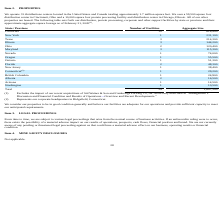From Chefs Wharehouse's financial document, What is the number of facilities in California and New York respectively? The document shows two values: 10 and 1. From the document: "California 10 618,900 California 10 618,900..." Also, What is the number of facilities in Texas and Illinois respectively? The document shows two values: 3 and 3. From the document: "New York 1 231,100..." Also, What is the number of facilities in Ohio and Maryland respectively? The document shows two values: 2 and 3. From the document: "New York 1 231,100 New York 1 231,100..." Also, can you calculate: What is the difference in the number of facilities between California and New York? Based on the calculation: 10-1, the result is 9. This is based on the information: "California 10 618,900 California 10 618,900..." The key data points involved are: 1, 10. Also, can you calculate: What is the average aggregate size of the facilities in Arizona and Washington? To answer this question, I need to perform calculations using the financial data. The calculation is: (14,500+ 10,500)/2, which equals 12500. This is based on the information: "Arizona 1 14,500 Washington 1 10,500..." The key data points involved are: 10,500, 14,500. Also, How many states have more than 5 facilities? Based on the analysis, there are 1 instances. The counting process: California. 